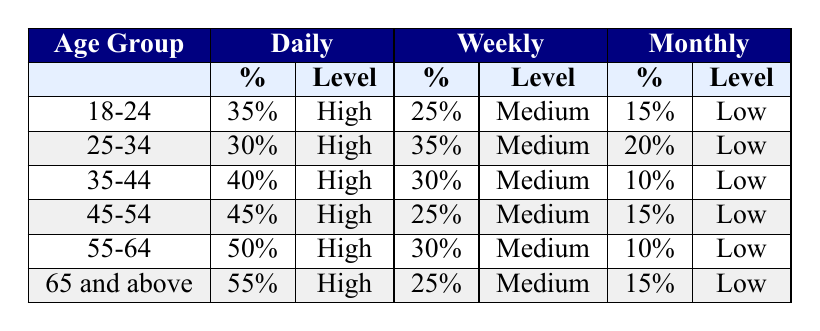What is the percentage of Catholics aged 65 and above who pray daily? In the table, under the age group 65 and above, the daily prayer percentage is stated as 55%.
Answer: 55% Which age group has the lowest percentage of monthly prayer frequency? Comparing the monthly frequencies across all age groups, the age group 35-44 has the lowest percentage, which is 10%.
Answer: 35-44 How many age groups have a daily prayer percentage of 40% or more? Looking through the table, the age groups 35-44 (40%), 45-54 (45%), 55-64 (50%), and 65 and above (55%) all have daily prayer percentages of 40% or more. That makes a total of four age groups.
Answer: 4 Is it true that the age group 18-24 has a higher percentage of daily prayers than the age group 25-34? The table shows that the 18-24 age group has a daily prayer percentage of 35%, while the 25-34 age group has a daily prayer percentage of 30%. Since 35% is greater than 30%, the statement is true.
Answer: Yes What is the average percentage of weekly prayer frequency across all age groups? The weekly percentages for each age group are: 25% (18-24), 35% (25-34), 30% (35-44), 25% (45-54), 30% (55-64), and 25% (65 and above). Adding these gives a total of 25 + 35 + 30 + 25 + 30 + 25 =  200. There are 6 age groups, so the average is 200/6 = 33.33%.
Answer: 33.33% 